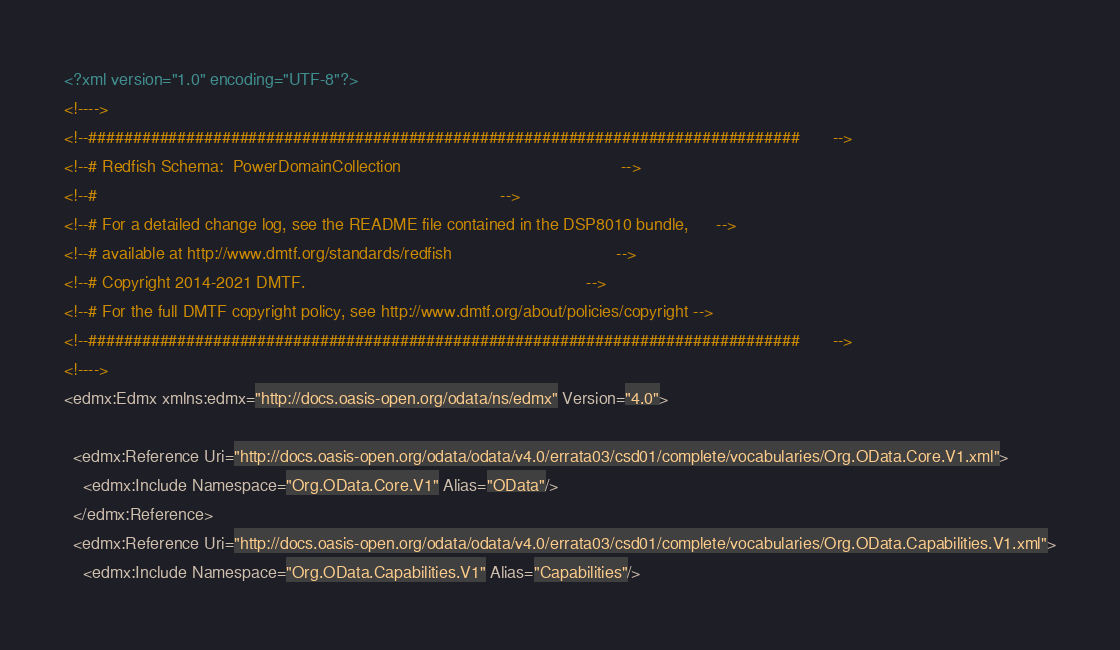Convert code to text. <code><loc_0><loc_0><loc_500><loc_500><_XML_><?xml version="1.0" encoding="UTF-8"?>
<!---->
<!--################################################################################       -->
<!--# Redfish Schema:  PowerDomainCollection                                               -->
<!--#                                                                                      -->
<!--# For a detailed change log, see the README file contained in the DSP8010 bundle,      -->
<!--# available at http://www.dmtf.org/standards/redfish                                   -->
<!--# Copyright 2014-2021 DMTF.                                                            -->
<!--# For the full DMTF copyright policy, see http://www.dmtf.org/about/policies/copyright -->
<!--################################################################################       -->
<!---->
<edmx:Edmx xmlns:edmx="http://docs.oasis-open.org/odata/ns/edmx" Version="4.0">

  <edmx:Reference Uri="http://docs.oasis-open.org/odata/odata/v4.0/errata03/csd01/complete/vocabularies/Org.OData.Core.V1.xml">
    <edmx:Include Namespace="Org.OData.Core.V1" Alias="OData"/>
  </edmx:Reference>
  <edmx:Reference Uri="http://docs.oasis-open.org/odata/odata/v4.0/errata03/csd01/complete/vocabularies/Org.OData.Capabilities.V1.xml">
    <edmx:Include Namespace="Org.OData.Capabilities.V1" Alias="Capabilities"/></code> 